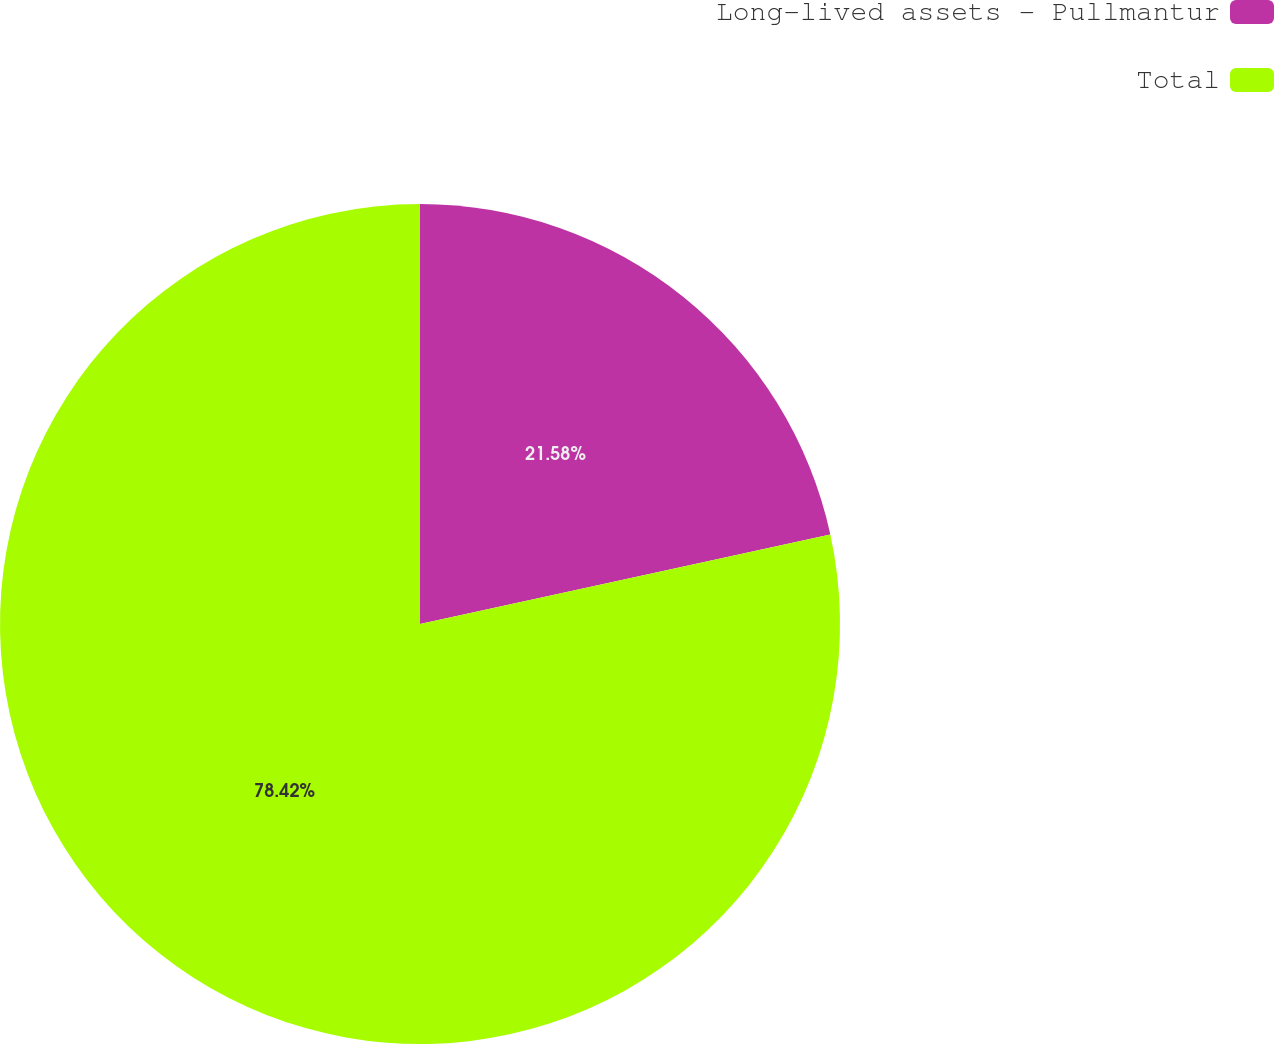<chart> <loc_0><loc_0><loc_500><loc_500><pie_chart><fcel>Long-lived assets - Pullmantur<fcel>Total<nl><fcel>21.58%<fcel>78.42%<nl></chart> 